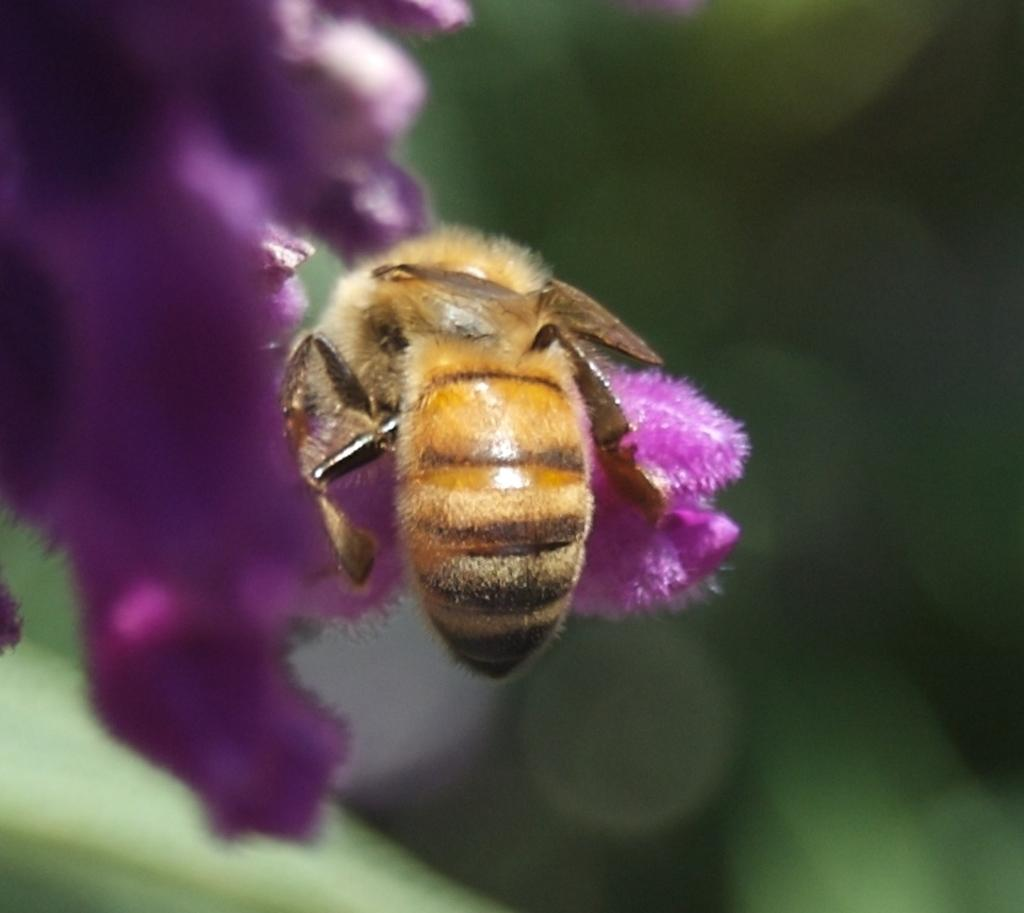What is the main subject of the image? There is a bee in the image. Where is the bee located in the image? The bee is on a flower. Can you describe the background of the image? The background of the image is blurred. What type of train can be seen in the background of the image? There is no train present in the image; it features a bee on a flower with a blurred background. 